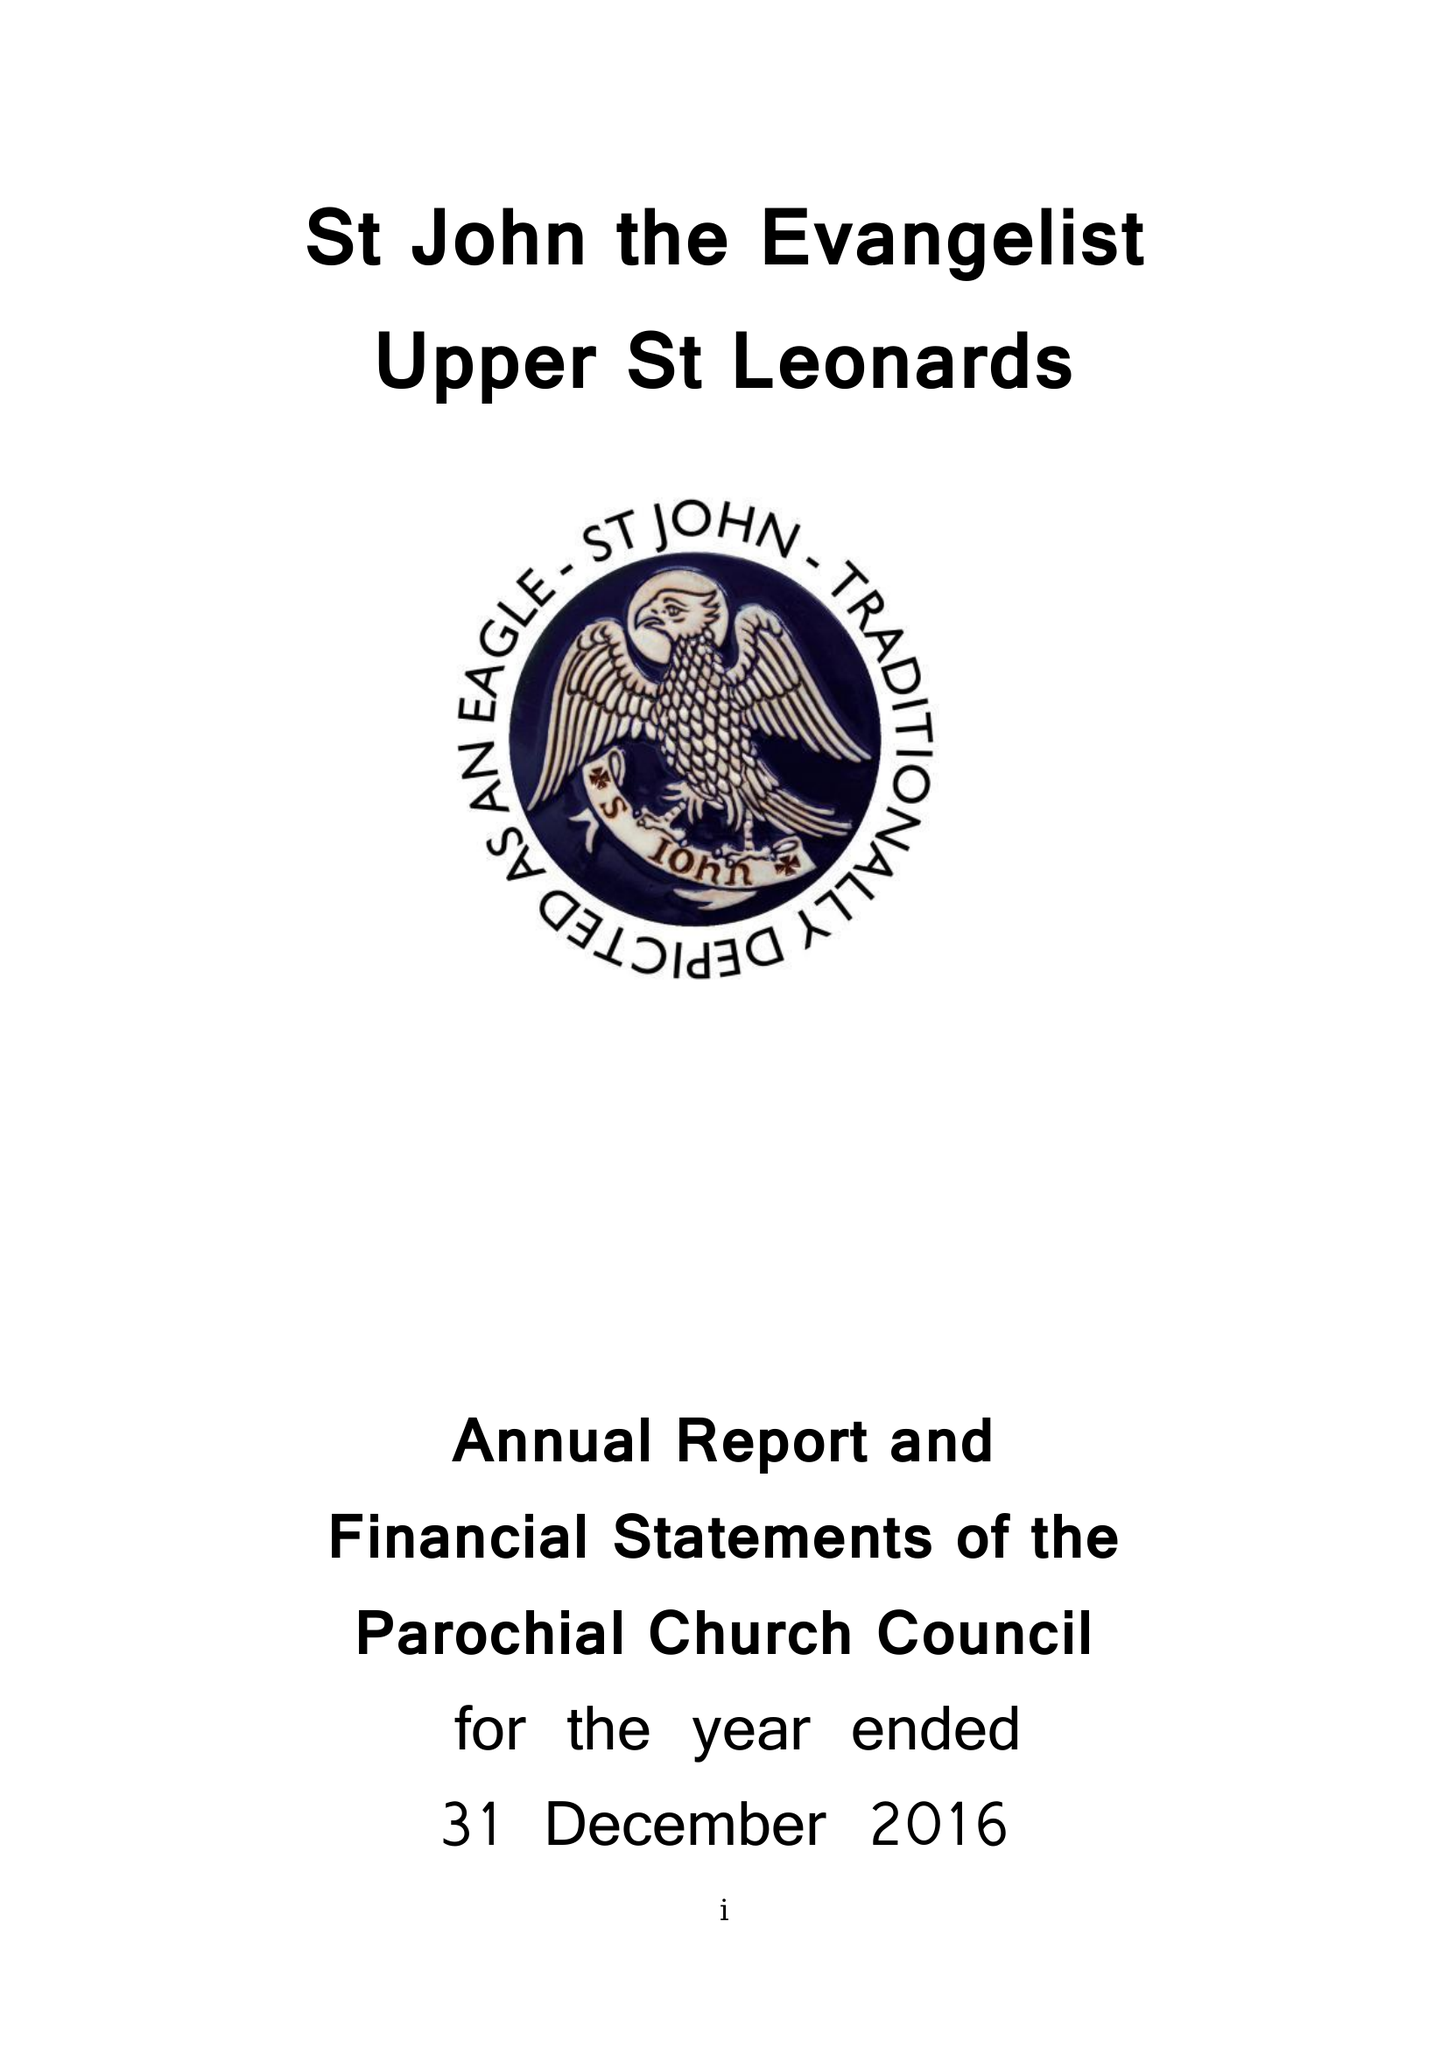What is the value for the charity_number?
Answer the question using a single word or phrase. 1132339 